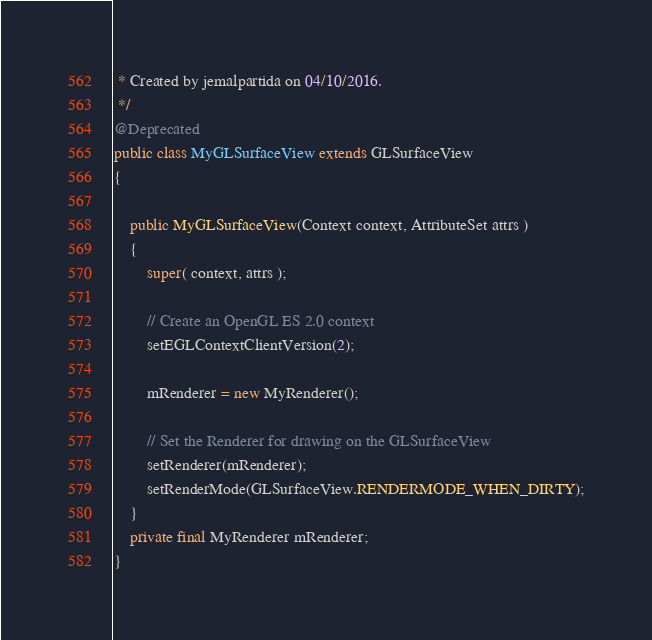<code> <loc_0><loc_0><loc_500><loc_500><_Java_> * Created by jemalpartida on 04/10/2016.
 */
@Deprecated
public class MyGLSurfaceView extends GLSurfaceView
{

    public MyGLSurfaceView(Context context, AttributeSet attrs )
    {
        super( context, attrs );

        // Create an OpenGL ES 2.0 context
        setEGLContextClientVersion(2);

        mRenderer = new MyRenderer();

        // Set the Renderer for drawing on the GLSurfaceView
        setRenderer(mRenderer);
        setRenderMode(GLSurfaceView.RENDERMODE_WHEN_DIRTY);
    }
    private final MyRenderer mRenderer;
}
</code> 